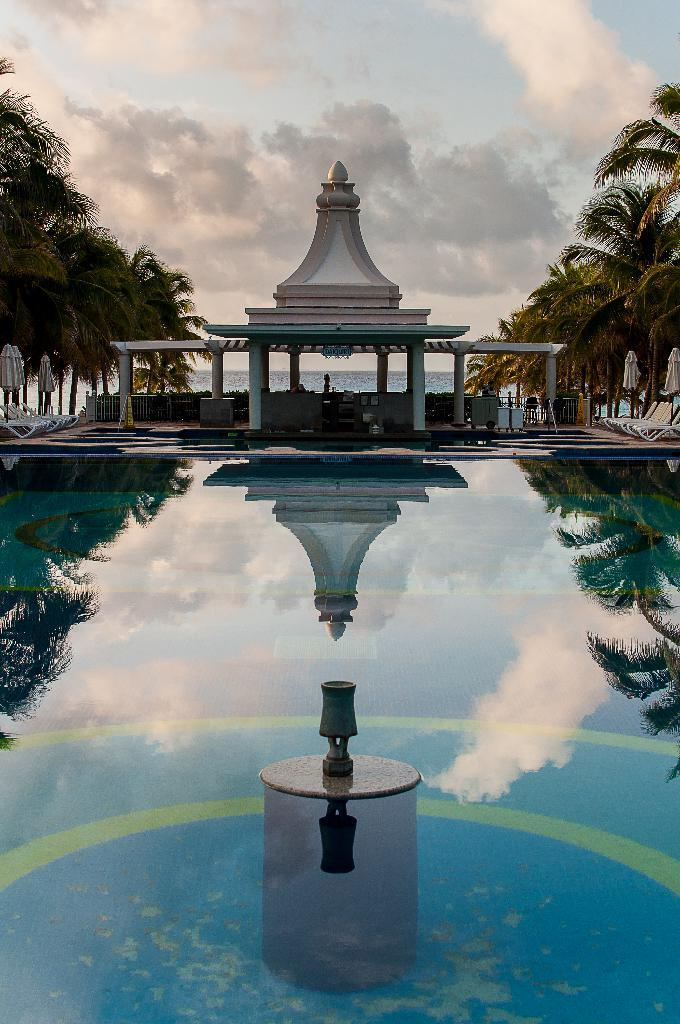What is the primary element in the image? The image consists of water. Where might the water be located? The water appears to be in a swimming pool. What can be seen on the sides of the image? There are trees on both the left and right sides of the image. What is visible in the sky at the top of the image? There are clouds visible in the sky at the top of the image. Can you tell me where the key is located in the image? There is no key present in the image. Did an earthquake occur in the image? There is no indication of an earthquake in the image. 